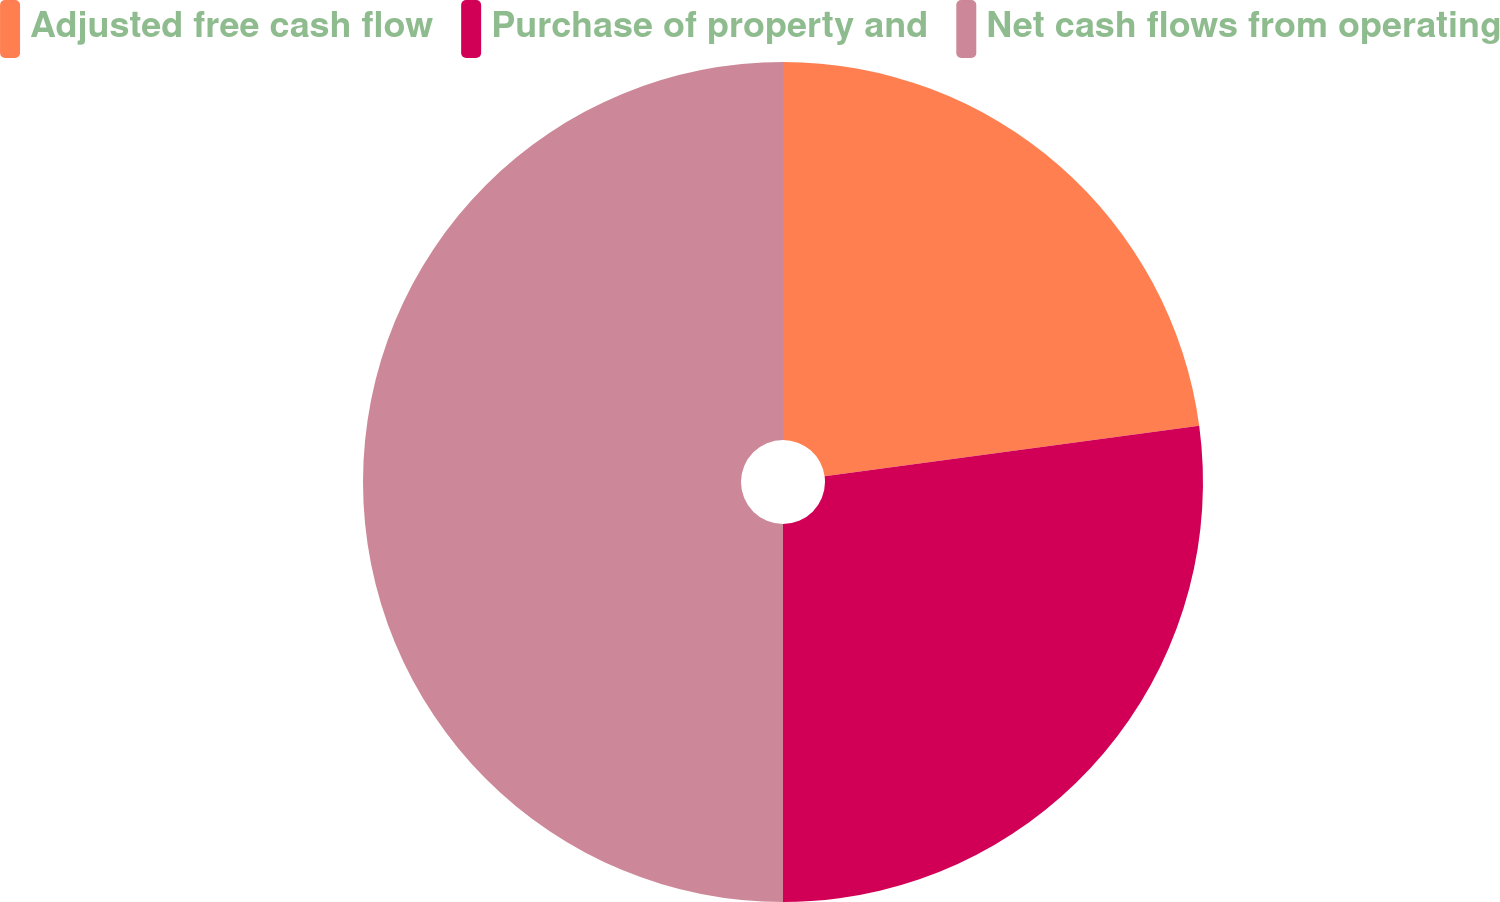<chart> <loc_0><loc_0><loc_500><loc_500><pie_chart><fcel>Adjusted free cash flow<fcel>Purchase of property and<fcel>Net cash flows from operating<nl><fcel>22.86%<fcel>27.14%<fcel>50.0%<nl></chart> 